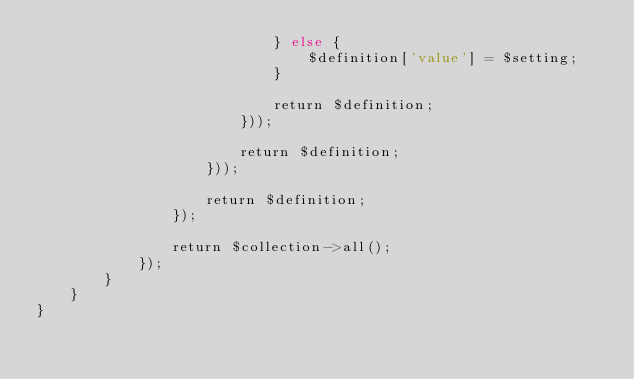<code> <loc_0><loc_0><loc_500><loc_500><_PHP_>                            } else {
                                $definition['value'] = $setting;
                            }

                            return $definition;
                        }));

                        return $definition;
                    }));

                    return $definition;
                });

                return $collection->all();
            });
        }
    }
}
</code> 